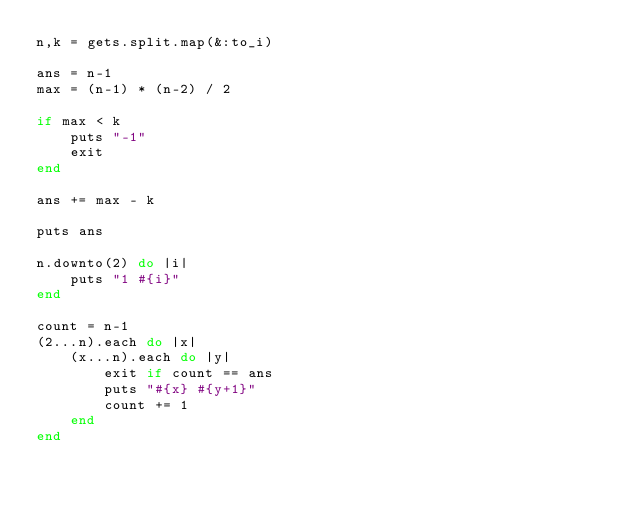Convert code to text. <code><loc_0><loc_0><loc_500><loc_500><_Ruby_>n,k = gets.split.map(&:to_i)

ans = n-1
max = (n-1) * (n-2) / 2

if max < k
	puts "-1"
	exit
end

ans += max - k

puts ans

n.downto(2) do |i|
	puts "1 #{i}"
end

count = n-1
(2...n).each do |x|
	(x...n).each do |y|
		exit if count == ans
		puts "#{x} #{y+1}"
		count += 1
	end
end</code> 